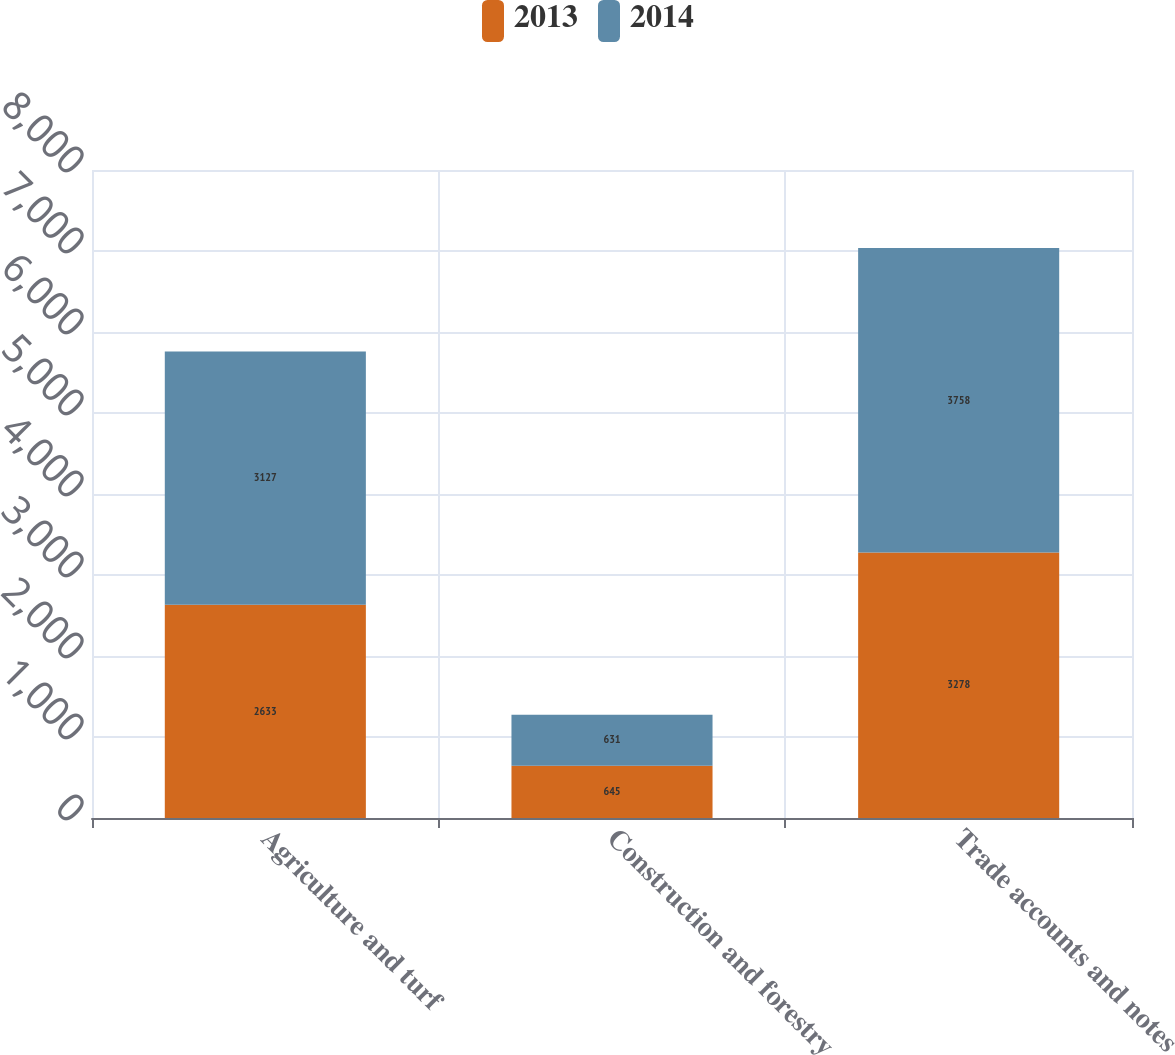<chart> <loc_0><loc_0><loc_500><loc_500><stacked_bar_chart><ecel><fcel>Agriculture and turf<fcel>Construction and forestry<fcel>Trade accounts and notes<nl><fcel>2013<fcel>2633<fcel>645<fcel>3278<nl><fcel>2014<fcel>3127<fcel>631<fcel>3758<nl></chart> 